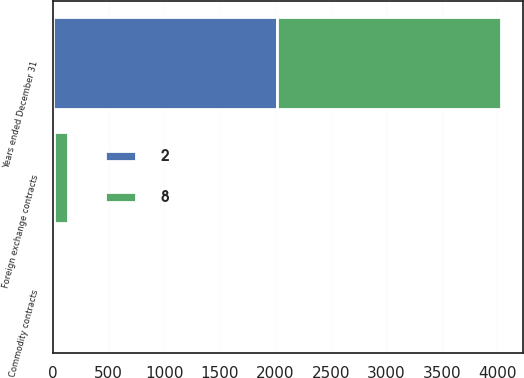Convert chart to OTSL. <chart><loc_0><loc_0><loc_500><loc_500><stacked_bar_chart><ecel><fcel>Years ended December 31<fcel>Foreign exchange contracts<fcel>Commodity contracts<nl><fcel>8<fcel>2017<fcel>123<fcel>4<nl><fcel>2<fcel>2016<fcel>9<fcel>1<nl></chart> 